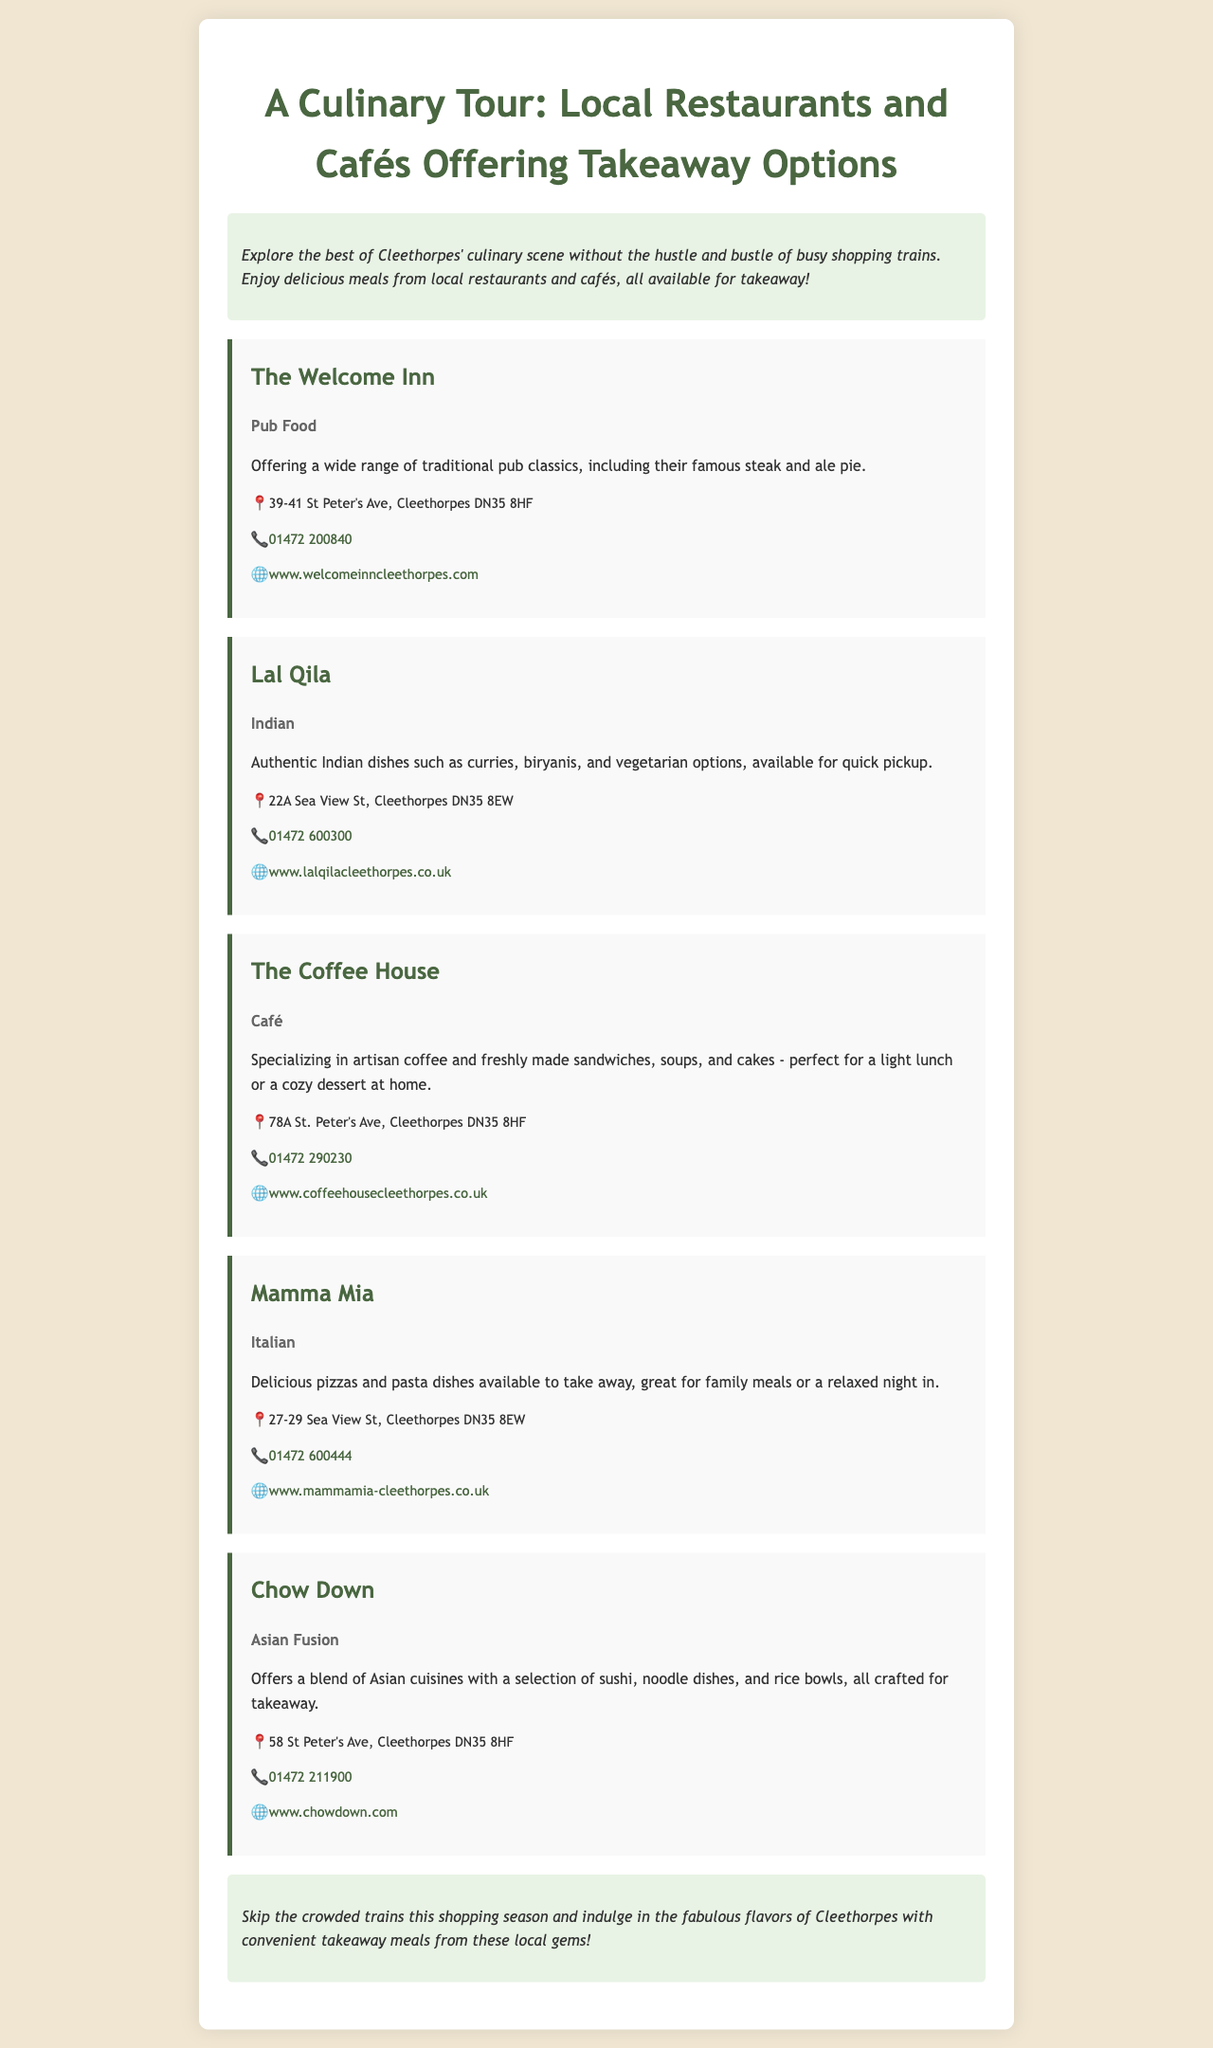what is the title of the brochure? The title of the brochure is presented prominently at the top of the document.
Answer: A Culinary Tour: Local Restaurants and Cafés Offering Takeaway Options how many restaurants are listed in the brochure? The brochure includes several sections, each dedicated to a different restaurant, allowing us to count them.
Answer: 5 what type of cuisine does The Welcome Inn serve? The type of cuisine is specified in the description of The Welcome Inn within the document.
Answer: Pub Food which restaurant offers Asian Fusion cuisine? The specific cuisine type is mentioned alongside the restaurant name in the brochure, allowing identification.
Answer: Chow Down what is the contact number for Lal Qila? The contact number for each restaurant is clearly stated in the contact section of their respective descriptions.
Answer: 01472 600300 where is Mamma Mia located? The location is found in the contact details for Mamma Mia, providing the address as noted in the document.
Answer: 27-29 Sea View St, Cleethorpes DN35 8EW which restaurant specializes in artisan coffee? The brochure highlights the specialties of each restaurant, allowing identification based on the description.
Answer: The Coffee House what is the concluding message of the brochure? The concluding section summarizes the intent of the brochure, providing a final takeaway message.
Answer: Skip the crowded trains this shopping season and indulge in the fabulous flavors of Cleethorpes with convenient takeaway meals from these local gems! 